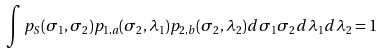Convert formula to latex. <formula><loc_0><loc_0><loc_500><loc_500>\int p _ { S } ( \sigma _ { 1 } , \sigma _ { 2 } ) p _ { 1 , a } ( \sigma _ { 2 } , \lambda _ { 1 } ) p _ { 2 , b } ( \sigma _ { 2 } , \lambda _ { 2 } ) d \sigma _ { 1 } \sigma _ { 2 } d \lambda _ { 1 } d \lambda _ { 2 } = 1</formula> 